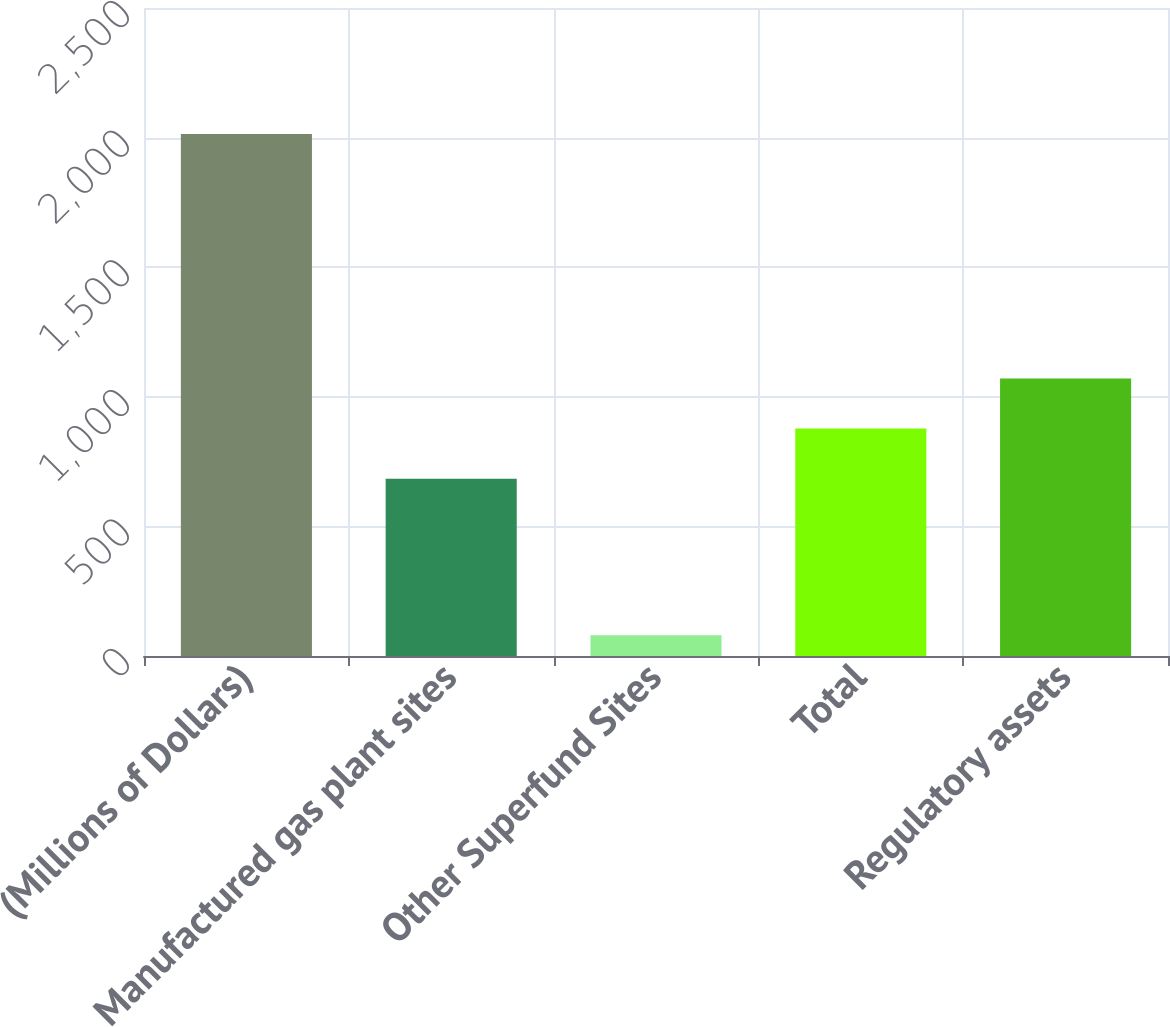Convert chart. <chart><loc_0><loc_0><loc_500><loc_500><bar_chart><fcel>(Millions of Dollars)<fcel>Manufactured gas plant sites<fcel>Other Superfund Sites<fcel>Total<fcel>Regulatory assets<nl><fcel>2014<fcel>684<fcel>80<fcel>877.4<fcel>1070.8<nl></chart> 